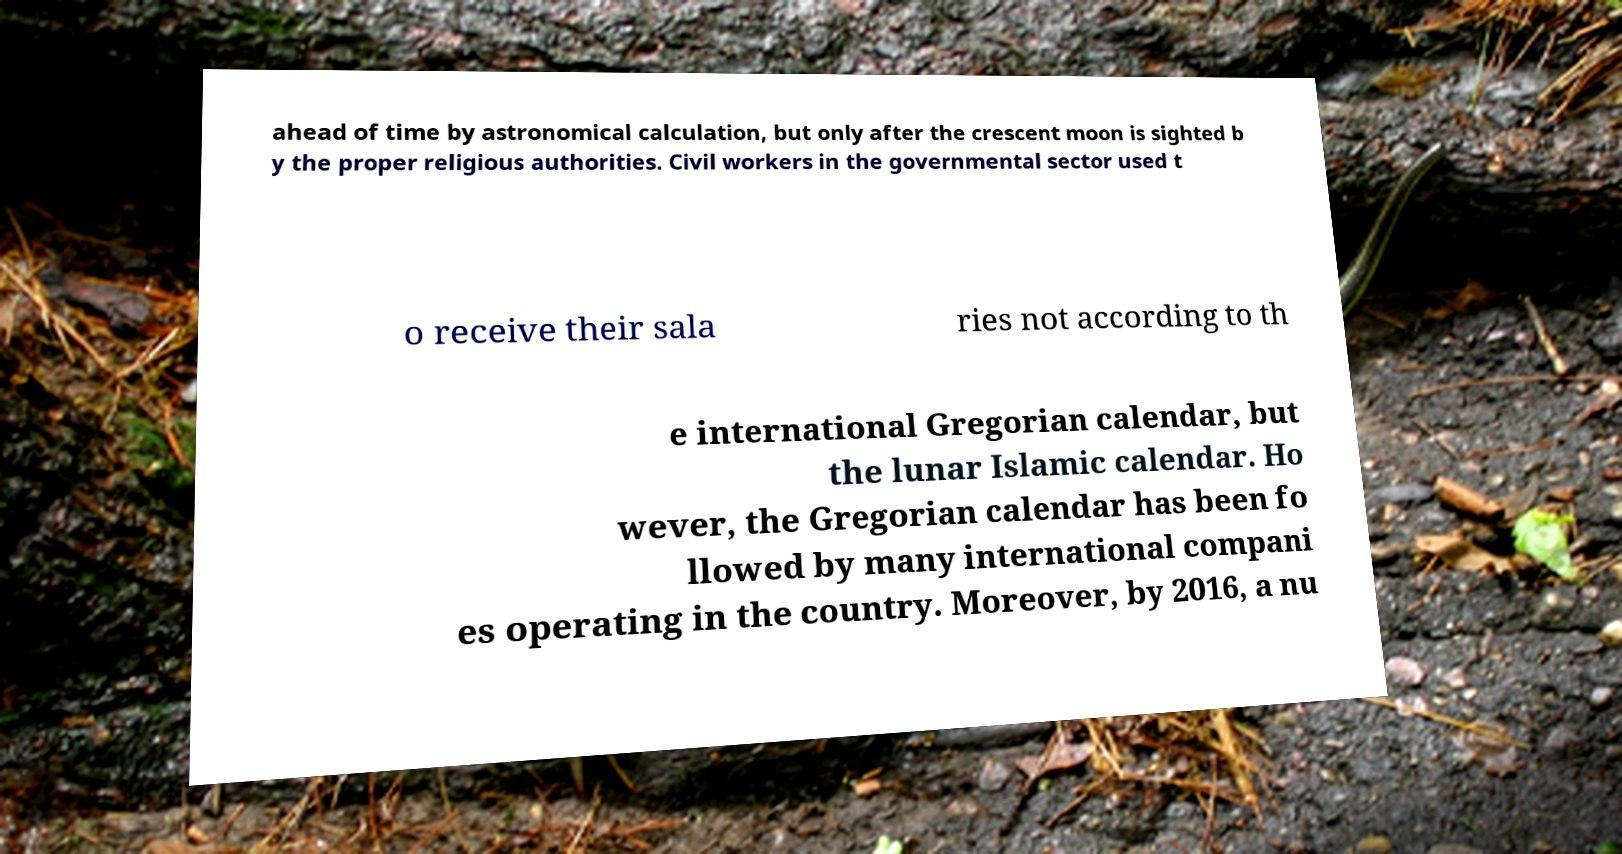I need the written content from this picture converted into text. Can you do that? ahead of time by astronomical calculation, but only after the crescent moon is sighted b y the proper religious authorities. Civil workers in the governmental sector used t o receive their sala ries not according to th e international Gregorian calendar, but the lunar Islamic calendar. Ho wever, the Gregorian calendar has been fo llowed by many international compani es operating in the country. Moreover, by 2016, a nu 